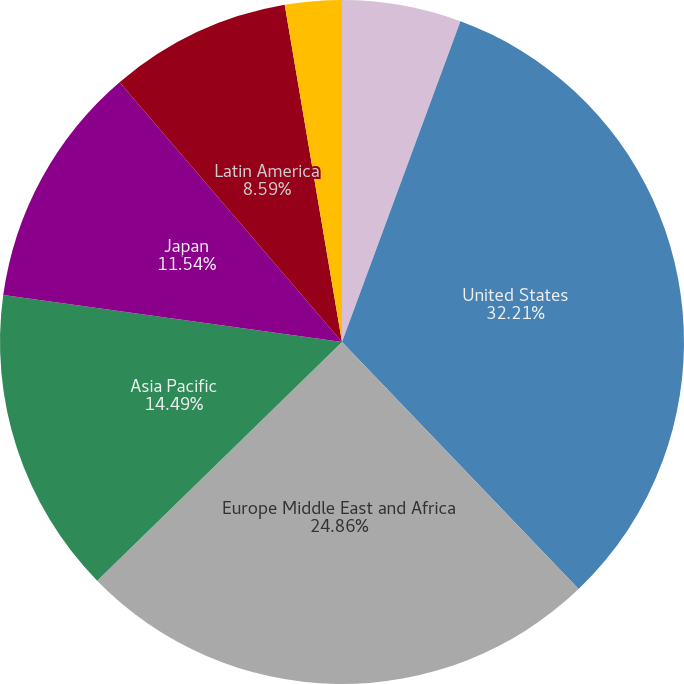Convert chart. <chart><loc_0><loc_0><loc_500><loc_500><pie_chart><fcel>Years Ended December 31<fcel>United States<fcel>Europe Middle East and Africa<fcel>Asia Pacific<fcel>Japan<fcel>Latin America<fcel>Other<nl><fcel>5.63%<fcel>32.21%<fcel>24.86%<fcel>14.49%<fcel>11.54%<fcel>8.59%<fcel>2.68%<nl></chart> 